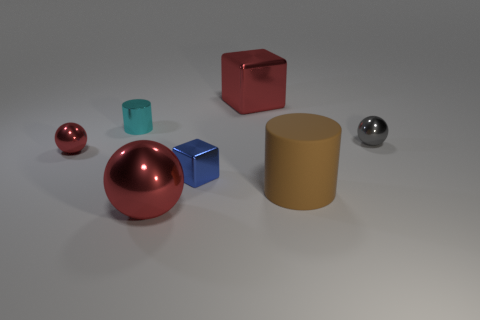Add 1 brown cylinders. How many objects exist? 8 Subtract all cylinders. How many objects are left? 5 Subtract all cyan things. Subtract all large cylinders. How many objects are left? 5 Add 4 tiny gray metal spheres. How many tiny gray metal spheres are left? 5 Add 2 large blue rubber balls. How many large blue rubber balls exist? 2 Subtract 0 yellow cylinders. How many objects are left? 7 